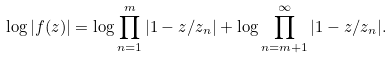<formula> <loc_0><loc_0><loc_500><loc_500>\log | f ( z ) | = \log \prod _ { n = 1 } ^ { m } | 1 - z / z _ { n } | + \log \prod _ { n = m + 1 } ^ { \infty } | 1 - z / z _ { n } | .</formula> 